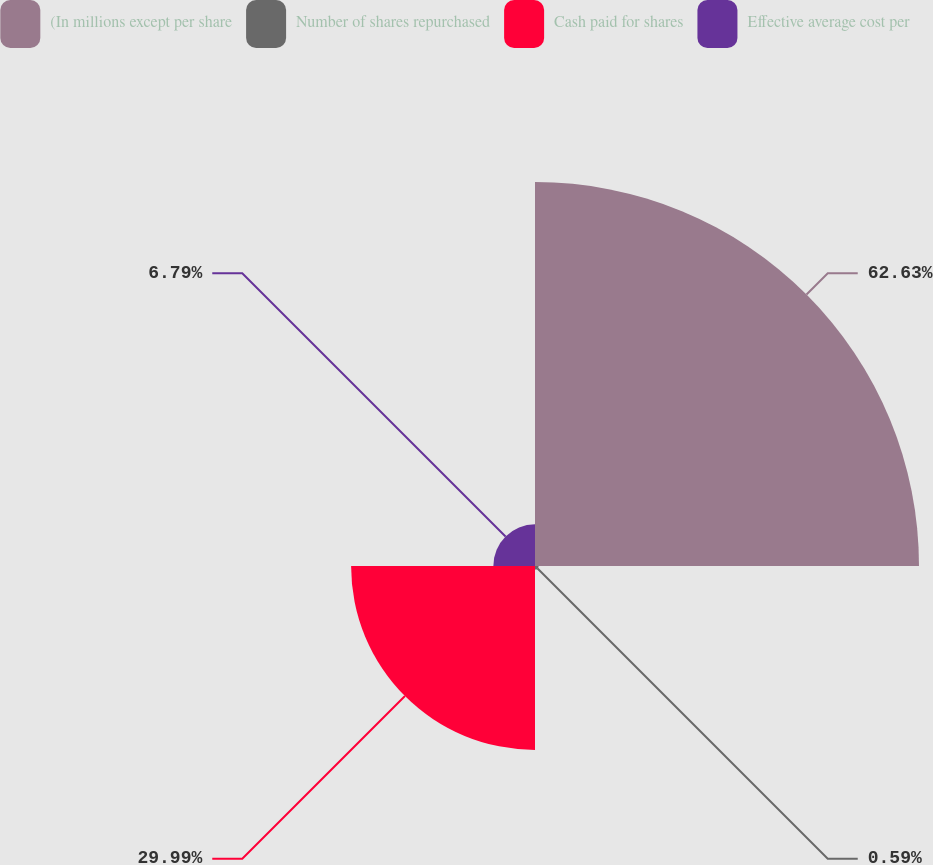Convert chart. <chart><loc_0><loc_0><loc_500><loc_500><pie_chart><fcel>(In millions except per share<fcel>Number of shares repurchased<fcel>Cash paid for shares<fcel>Effective average cost per<nl><fcel>62.62%<fcel>0.59%<fcel>29.99%<fcel>6.79%<nl></chart> 